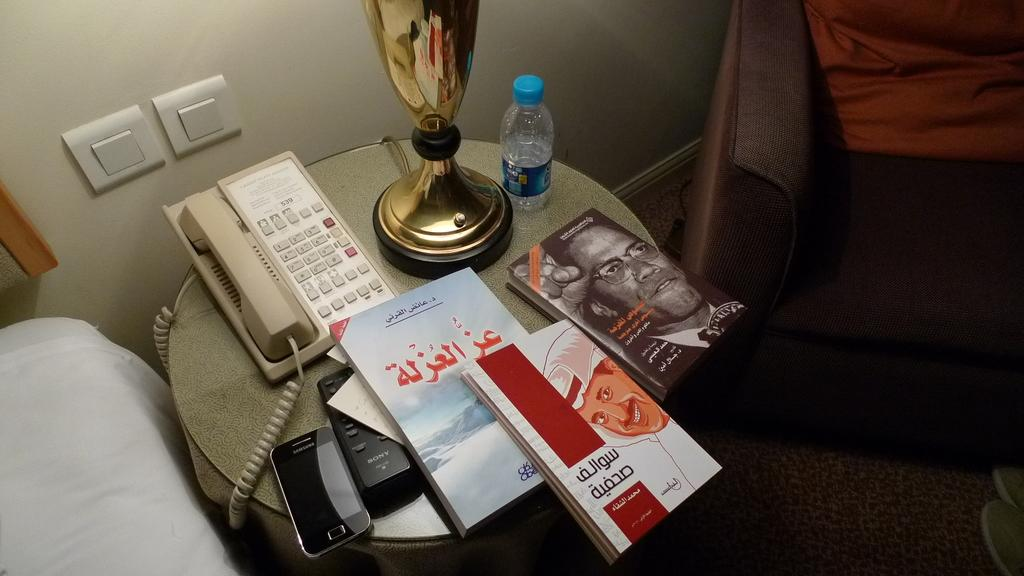Provide a one-sentence caption for the provided image. Room number 539 is displayed on the phone on a bedside table that also includes various books and a Samsung phone. 